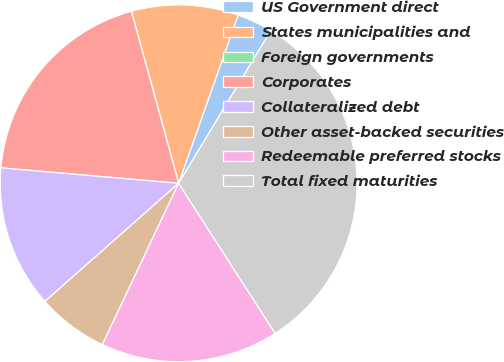<chart> <loc_0><loc_0><loc_500><loc_500><pie_chart><fcel>US Government direct<fcel>States municipalities and<fcel>Foreign governments<fcel>Corporates<fcel>Collateralized debt<fcel>Other asset-backed securities<fcel>Redeemable preferred stocks<fcel>Total fixed maturities<nl><fcel>3.23%<fcel>9.68%<fcel>0.0%<fcel>19.35%<fcel>12.9%<fcel>6.45%<fcel>16.13%<fcel>32.26%<nl></chart> 